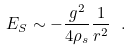<formula> <loc_0><loc_0><loc_500><loc_500>E _ { S } \sim - \frac { g ^ { 2 } } { 4 \rho _ { s } } \frac { 1 } { r ^ { 2 } } \ .</formula> 